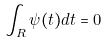Convert formula to latex. <formula><loc_0><loc_0><loc_500><loc_500>\int _ { R } \psi ( t ) d t = 0</formula> 